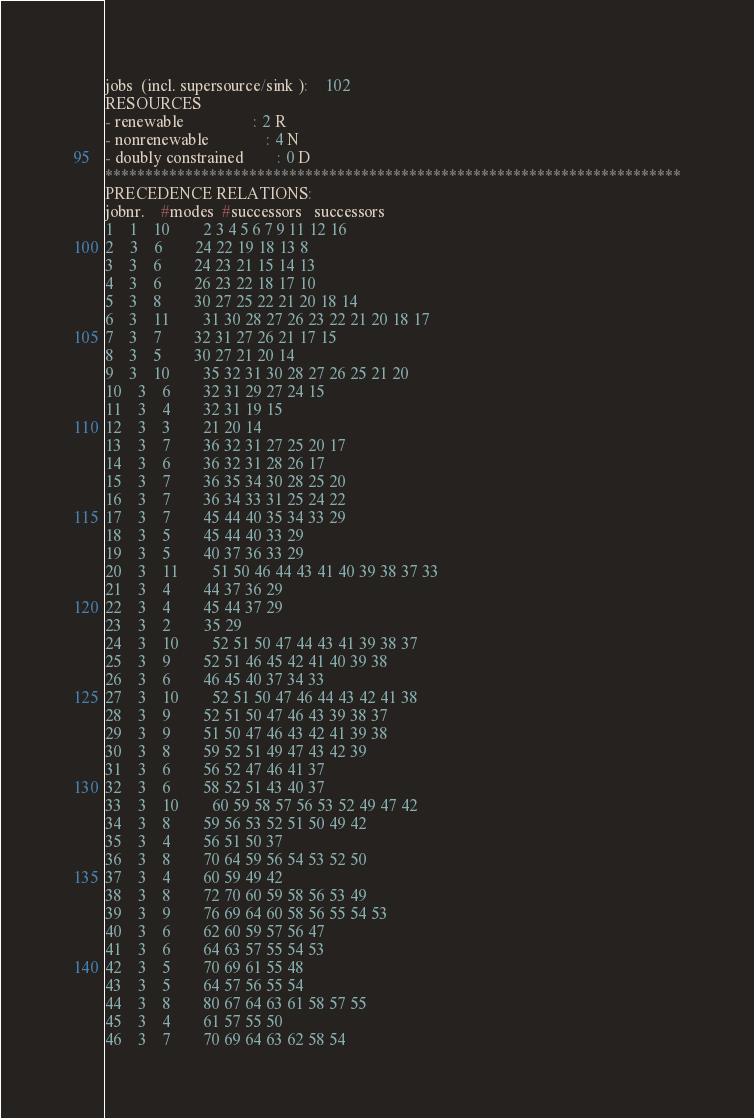Convert code to text. <code><loc_0><loc_0><loc_500><loc_500><_ObjectiveC_>jobs  (incl. supersource/sink ):	102
RESOURCES
- renewable                 : 2 R
- nonrenewable              : 4 N
- doubly constrained        : 0 D
************************************************************************
PRECEDENCE RELATIONS:
jobnr.    #modes  #successors   successors
1	1	10		2 3 4 5 6 7 9 11 12 16 
2	3	6		24 22 19 18 13 8 
3	3	6		24 23 21 15 14 13 
4	3	6		26 23 22 18 17 10 
5	3	8		30 27 25 22 21 20 18 14 
6	3	11		31 30 28 27 26 23 22 21 20 18 17 
7	3	7		32 31 27 26 21 17 15 
8	3	5		30 27 21 20 14 
9	3	10		35 32 31 30 28 27 26 25 21 20 
10	3	6		32 31 29 27 24 15 
11	3	4		32 31 19 15 
12	3	3		21 20 14 
13	3	7		36 32 31 27 25 20 17 
14	3	6		36 32 31 28 26 17 
15	3	7		36 35 34 30 28 25 20 
16	3	7		36 34 33 31 25 24 22 
17	3	7		45 44 40 35 34 33 29 
18	3	5		45 44 40 33 29 
19	3	5		40 37 36 33 29 
20	3	11		51 50 46 44 43 41 40 39 38 37 33 
21	3	4		44 37 36 29 
22	3	4		45 44 37 29 
23	3	2		35 29 
24	3	10		52 51 50 47 44 43 41 39 38 37 
25	3	9		52 51 46 45 42 41 40 39 38 
26	3	6		46 45 40 37 34 33 
27	3	10		52 51 50 47 46 44 43 42 41 38 
28	3	9		52 51 50 47 46 43 39 38 37 
29	3	9		51 50 47 46 43 42 41 39 38 
30	3	8		59 52 51 49 47 43 42 39 
31	3	6		56 52 47 46 41 37 
32	3	6		58 52 51 43 40 37 
33	3	10		60 59 58 57 56 53 52 49 47 42 
34	3	8		59 56 53 52 51 50 49 42 
35	3	4		56 51 50 37 
36	3	8		70 64 59 56 54 53 52 50 
37	3	4		60 59 49 42 
38	3	8		72 70 60 59 58 56 53 49 
39	3	9		76 69 64 60 58 56 55 54 53 
40	3	6		62 60 59 57 56 47 
41	3	6		64 63 57 55 54 53 
42	3	5		70 69 61 55 48 
43	3	5		64 57 56 55 54 
44	3	8		80 67 64 63 61 58 57 55 
45	3	4		61 57 55 50 
46	3	7		70 69 64 63 62 58 54 </code> 